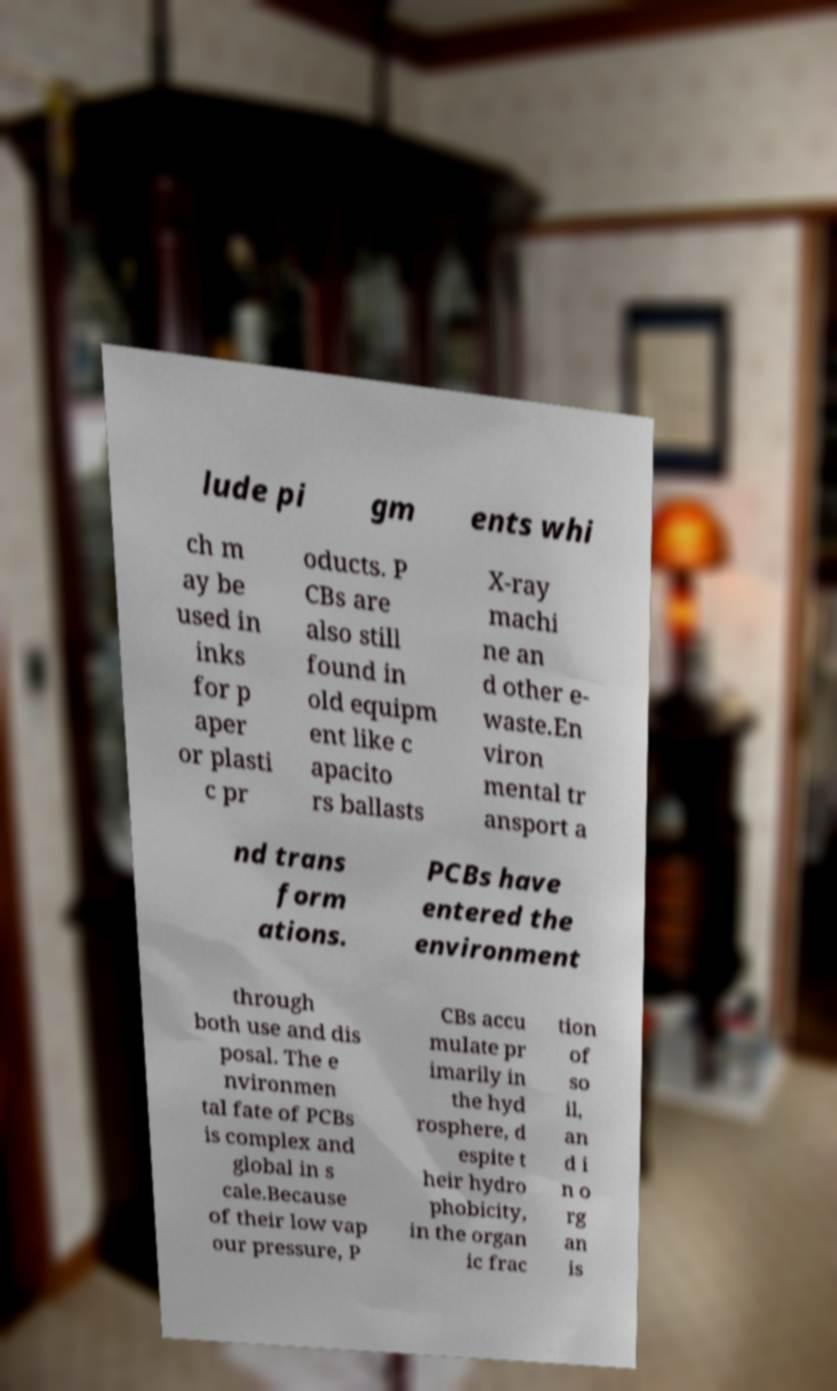Could you assist in decoding the text presented in this image and type it out clearly? lude pi gm ents whi ch m ay be used in inks for p aper or plasti c pr oducts. P CBs are also still found in old equipm ent like c apacito rs ballasts X-ray machi ne an d other e- waste.En viron mental tr ansport a nd trans form ations. PCBs have entered the environment through both use and dis posal. The e nvironmen tal fate of PCBs is complex and global in s cale.Because of their low vap our pressure, P CBs accu mulate pr imarily in the hyd rosphere, d espite t heir hydro phobicity, in the organ ic frac tion of so il, an d i n o rg an is 